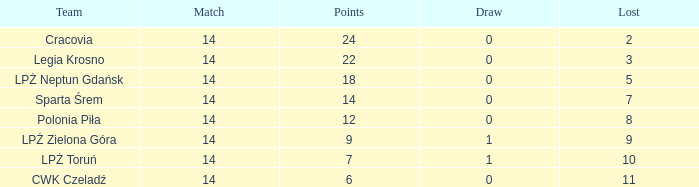What is the lowest points for a match before 14? None. 